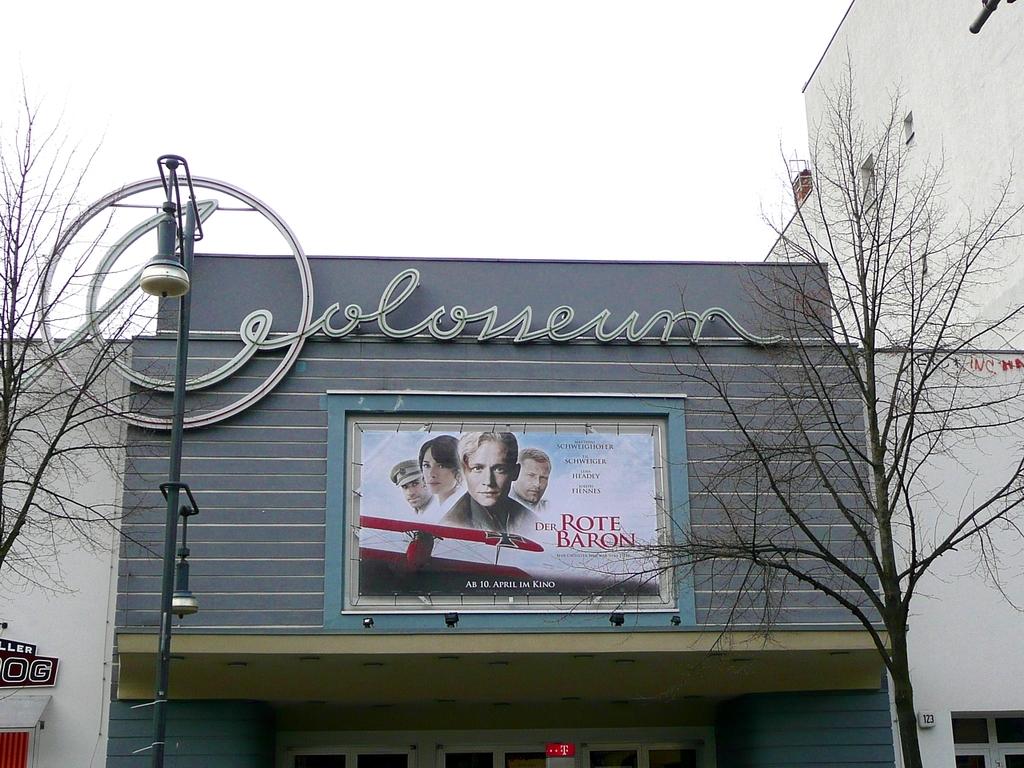What's the name of the movie being shown?
Give a very brief answer. The rote baron. What is the name of the theater?
Provide a short and direct response. Coloseum. 